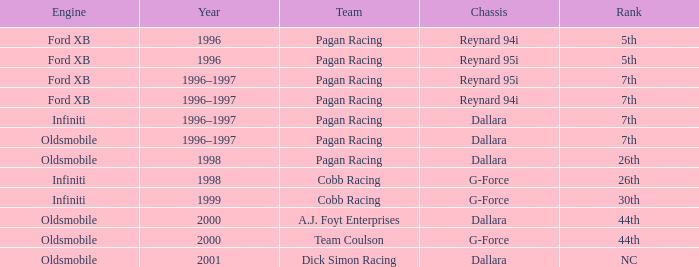What position did the reynard 94i chassis hold in the 1996 rankings? 5th. 